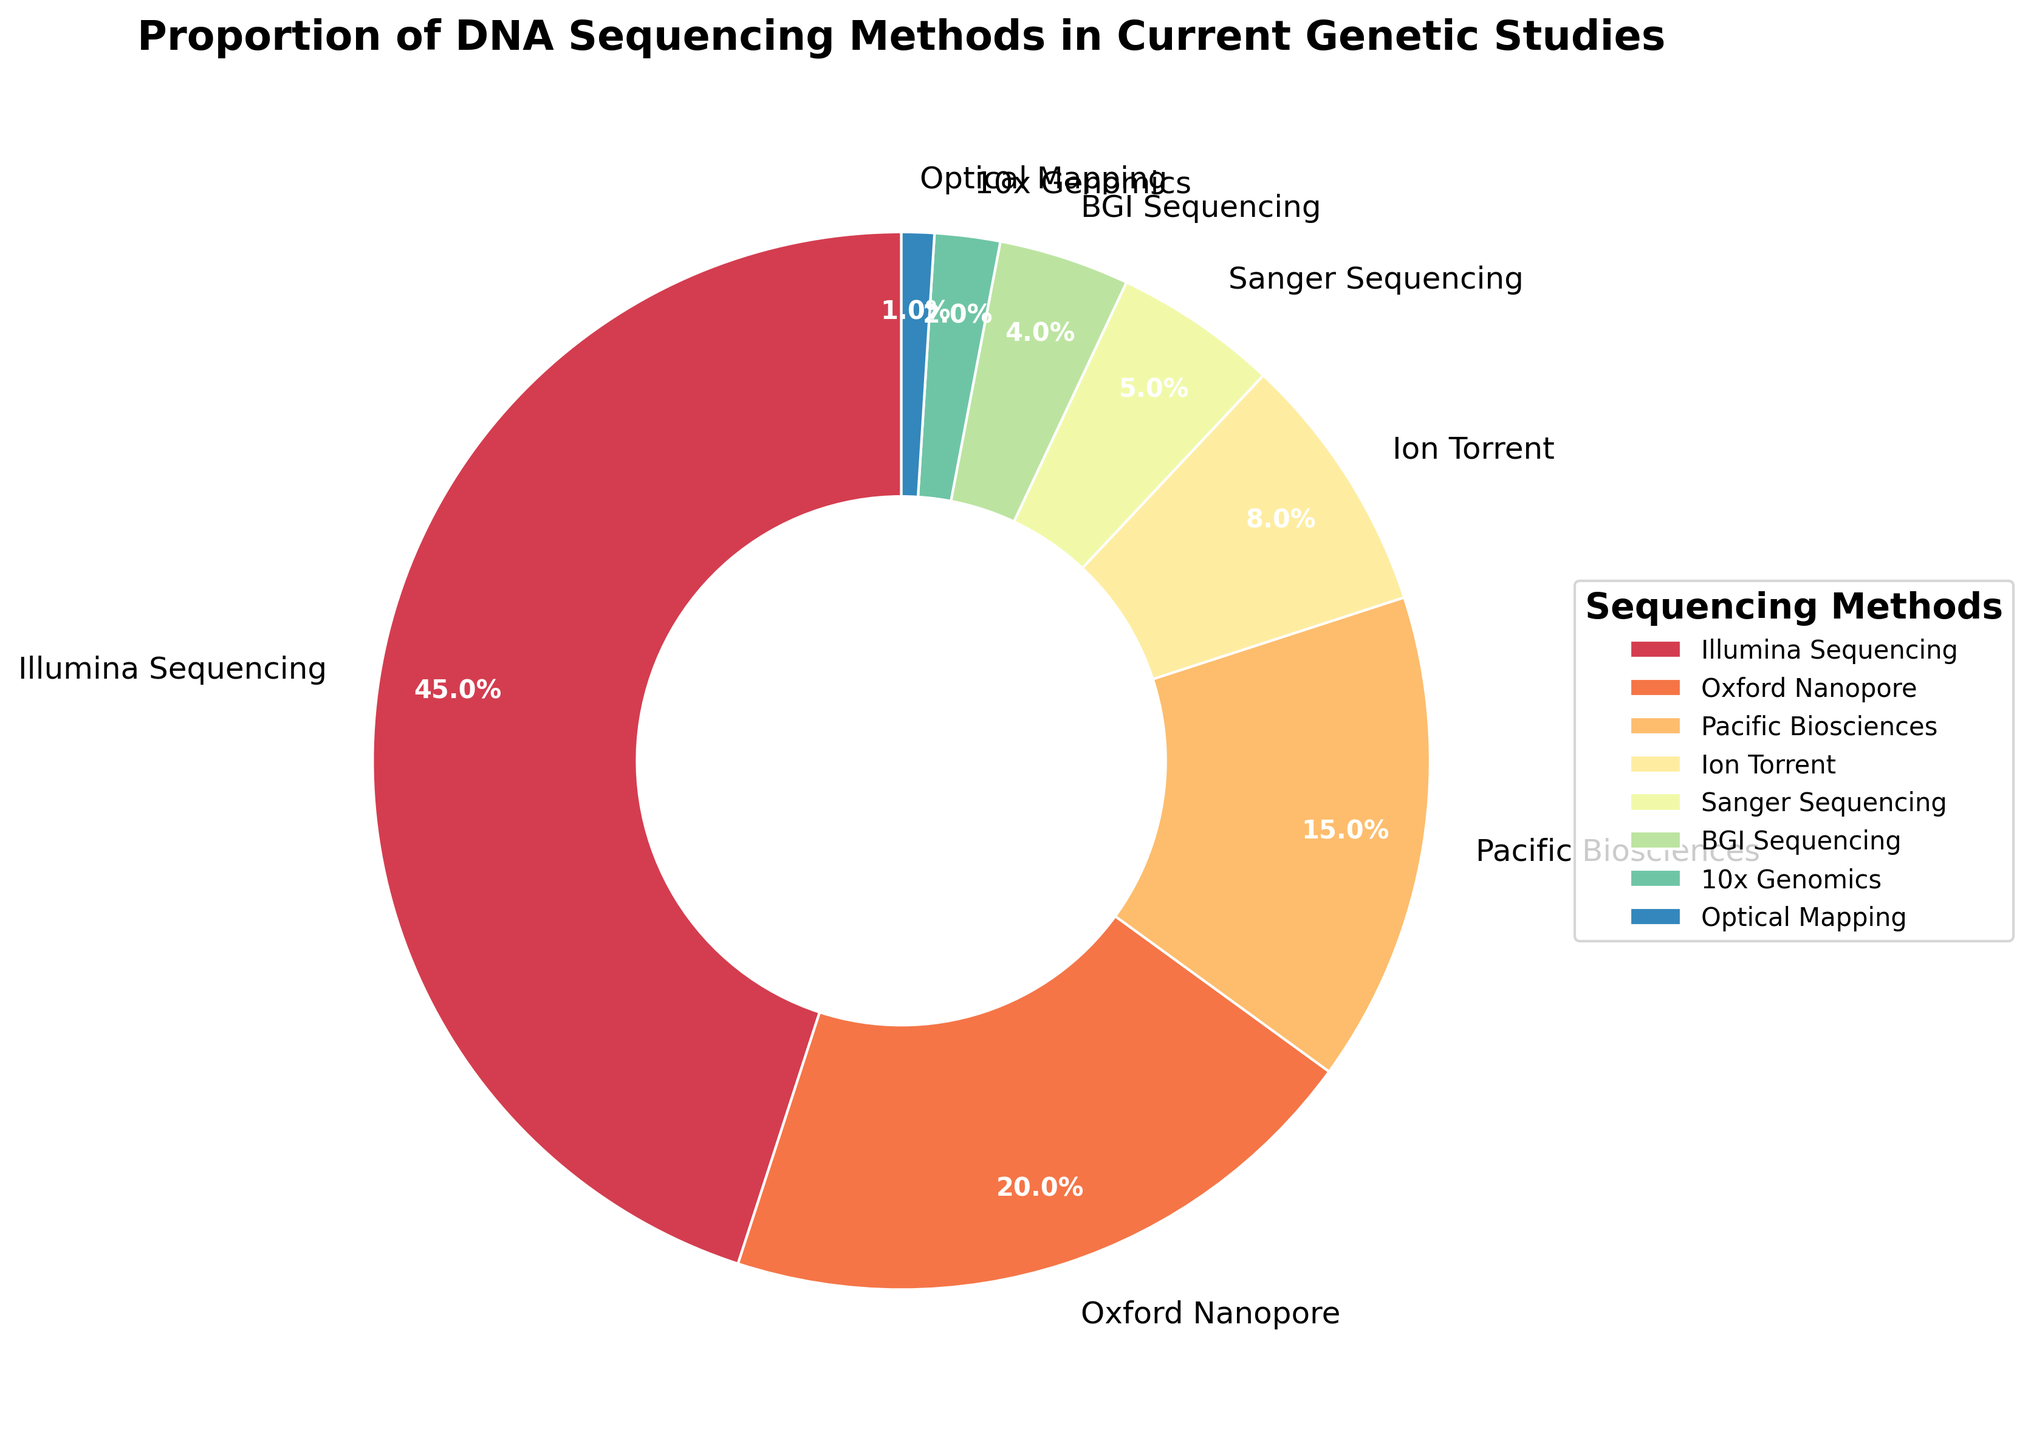Which sequencing method is the most commonly used? The method with the highest percentage on the pie chart is Illumina Sequencing, which is at 45%.
Answer: Illumina Sequencing Which sequencing method has the smallest proportion? The method with the smallest percentage on the pie chart is Optical Mapping, which is at 1%.
Answer: Optical Mapping How much higher is the proportion of Oxford Nanopore compared to Ion Torrent? The percentage for Oxford Nanopore is 20%, and for Ion Torrent, it is 8%. The difference is 20% - 8% = 12%.
Answer: 12% What is the combined proportion of Illumina Sequencing and Pacific Biosciences? The proportion of Illumina Sequencing is 45%, and for Pacific Biosciences, it is 15%. Their combined total is 45% + 15% = 60%.
Answer: 60% Which sequencing methods individually make up less than 5% of the total? The methods listed in the pie chart with less than 5% each are Sanger Sequencing (5%), BGI Sequencing (4%), 10x Genomics (2%), and Optical Mapping (1%).
Answer: Sanger Sequencing, BGI Sequencing, 10x Genomics, Optical Mapping What is the total percentage of methods besides Illumina Sequencing? Illumina Sequencing is 45%, so the remaining methods account for 100% - 45% = 55%.
Answer: 55% Which methods combined make up approximately half of the total percentage? The methods that combined make up approximately 50% are Oxford Nanopore (20%) and Pacific Biosciences (15%), and Ion Torrent (8%), and Sanger Sequencing (5%), together totaling 48%, which is close to 50%.
Answer: Oxford Nanopore, Pacific Biosciences, Ion Torrent, Sanger Sequencing 